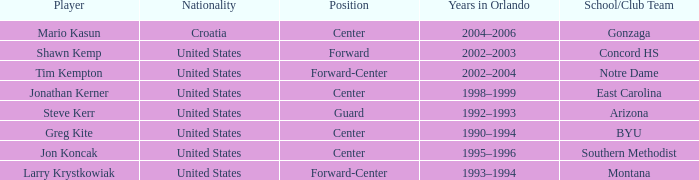What years in orlando have the United States as the nationality, and montana as the school/club team? 1993–1994. 